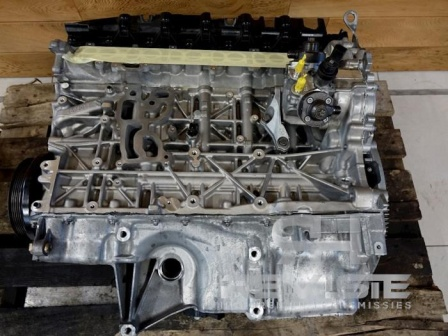What do you think this engine block's journey has been up until this point? Imagining the journey of this engine block, it might have started its journey in a manufacturing plant where it was cast and machined to precise specifications. Afterward, it would have been assembled with other essential engine components in an assembly line. From there, it might have journeyed through rigorous testing and quality checks to ensure it met all performance standards. If it's here now, it might indicate that it was removed from a vehicle, perhaps due to the need for repair or refurbishment. The dirt and minor wear signs suggest it has seen some use, possibly in a vehicle that covered many miles and transported people or goods, contributing significantly to its story. 